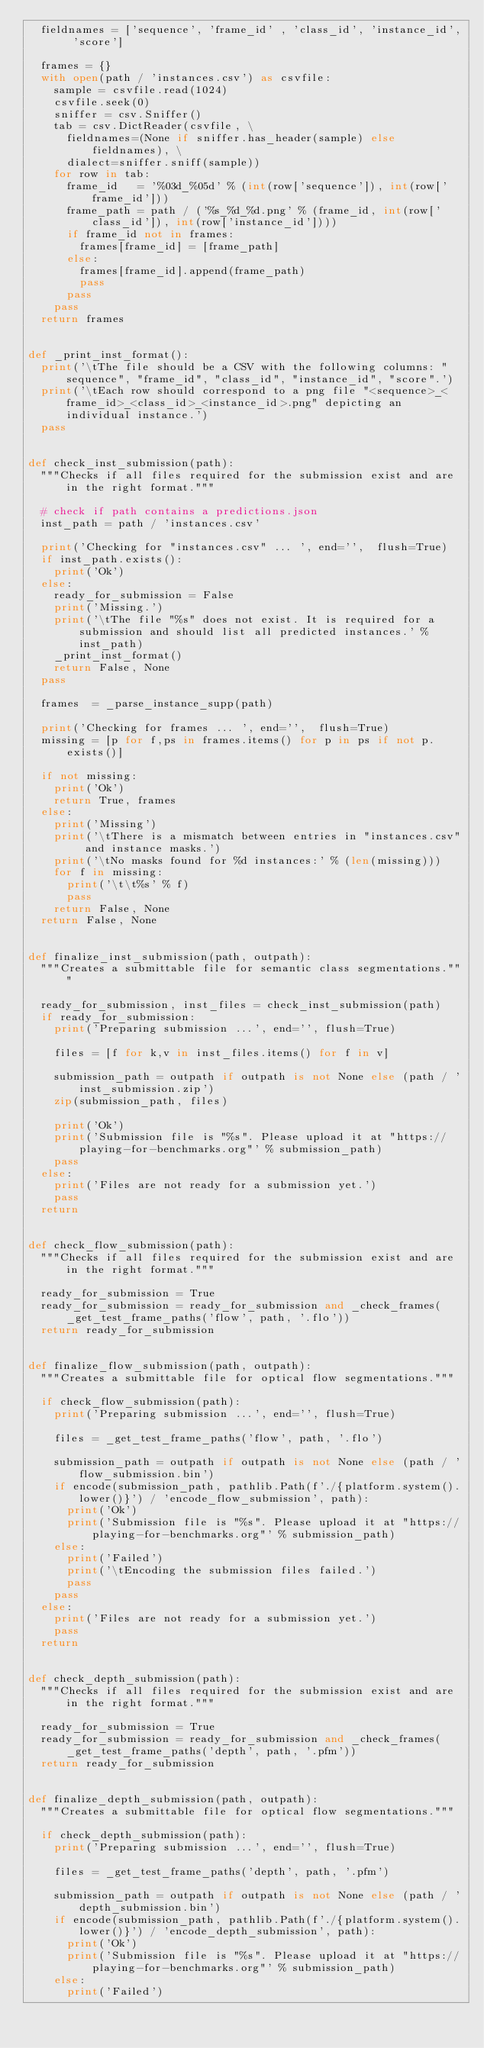<code> <loc_0><loc_0><loc_500><loc_500><_Python_>	fieldnames = ['sequence', 'frame_id' , 'class_id', 'instance_id', 'score']

	frames = {}
	with open(path / 'instances.csv') as csvfile:
		sample = csvfile.read(1024)
		csvfile.seek(0)
		sniffer = csv.Sniffer()
		tab = csv.DictReader(csvfile, \
			fieldnames=(None if sniffer.has_header(sample) else fieldnames), \
			dialect=sniffer.sniff(sample))
		for row in tab:
			frame_id   = '%03d_%05d' % (int(row['sequence']), int(row['frame_id']))
			frame_path = path / ('%s_%d_%d.png' % (frame_id, int(row['class_id']), int(row['instance_id'])))
			if frame_id not in frames:
				frames[frame_id] = [frame_path]
			else:
				frames[frame_id].append(frame_path)
				pass
			pass
		pass
	return frames


def _print_inst_format():
	print('\tThe file should be a CSV with the following columns: "sequence", "frame_id", "class_id", "instance_id", "score".')
	print('\tEach row should correspond to a png file "<sequence>_<frame_id>_<class_id>_<instance_id>.png" depicting an individual instance.')
	pass


def check_inst_submission(path):
	"""Checks if all files required for the submission exist and are in the right format."""

	# check if path contains a predictions.json
	inst_path = path / 'instances.csv'

	print('Checking for "instances.csv" ... ', end='',  flush=True)
	if inst_path.exists():
		print('Ok')		
	else:
		ready_for_submission = False
		print('Missing.')
		print('\tThe file "%s" does not exist. It is required for a submission and should list all predicted instances.' % inst_path)
		_print_inst_format()
		return False, None
	pass

	frames  = _parse_instance_supp(path)
	
	print('Checking for frames ... ', end='',  flush=True)
	missing = [p for f,ps in frames.items() for p in ps if not p.exists()]

	if not missing:
		print('Ok')
		return True, frames
	else:
		print('Missing')
		print('\tThere is a mismatch between entries in "instances.csv" and instance masks.')
		print('\tNo masks found for %d instances:' % (len(missing)))
		for f in missing:
			print('\t\t%s' % f)
			pass
		return False, None
	return False, None


def finalize_inst_submission(path, outpath):
	"""Creates a submittable file for semantic class segmentations."""

	ready_for_submission, inst_files = check_inst_submission(path)
	if ready_for_submission:
		print('Preparing submission ...', end='', flush=True)
		
		files = [f for k,v in inst_files.items() for f in v]
		
		submission_path = outpath if outpath is not None else (path / 'inst_submission.zip')
		zip(submission_path, files)
		
		print('Ok')
		print('Submission file is "%s". Please upload it at "https://playing-for-benchmarks.org"' % submission_path)
		pass
	else:
		print('Files are not ready for a submission yet.')
		pass
	return


def check_flow_submission(path):
	"""Checks if all files required for the submission exist and are in the right format."""

	ready_for_submission = True
	ready_for_submission = ready_for_submission and _check_frames(_get_test_frame_paths('flow', path, '.flo'))
	return ready_for_submission


def finalize_flow_submission(path, outpath):
	"""Creates a submittable file for optical flow segmentations."""

	if check_flow_submission(path):
		print('Preparing submission ...', end='', flush=True)
		
		files = _get_test_frame_paths('flow', path, '.flo')
		
		submission_path = outpath if outpath is not None else (path / 'flow_submission.bin')
		if encode(submission_path, pathlib.Path(f'./{platform.system().lower()}') / 'encode_flow_submission', path):
			print('Ok')
			print('Submission file is "%s". Please upload it at "https://playing-for-benchmarks.org"' % submission_path)
		else:
			print('Failed')
			print('\tEncoding the submission files failed.')
			pass
		pass
	else:
		print('Files are not ready for a submission yet.')
		pass
	return


def check_depth_submission(path):
	"""Checks if all files required for the submission exist and are in the right format."""

	ready_for_submission = True
	ready_for_submission = ready_for_submission and _check_frames(_get_test_frame_paths('depth', path, '.pfm'))
	return ready_for_submission


def finalize_depth_submission(path, outpath):
	"""Creates a submittable file for optical flow segmentations."""

	if check_depth_submission(path):
		print('Preparing submission ...', end='', flush=True)
		
		files = _get_test_frame_paths('depth', path, '.pfm')
		
		submission_path = outpath if outpath is not None else (path / 'depth_submission.bin')
		if encode(submission_path, pathlib.Path(f'./{platform.system().lower()}') / 'encode_depth_submission', path):
			print('Ok')
			print('Submission file is "%s". Please upload it at "https://playing-for-benchmarks.org"' % submission_path)
		else:
			print('Failed')</code> 